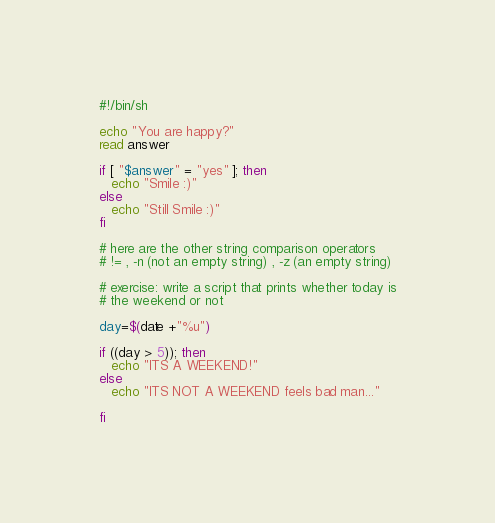<code> <loc_0><loc_0><loc_500><loc_500><_Bash_>#!/bin/sh

echo "You are happy?"
read answer

if [ "$answer" = "yes" ]; then
   echo "Smile :)"
else
   echo "Still Smile :)"
fi

# here are the other string comparison operators
# != , -n (not an empty string) , -z (an empty string)

# exercise: write a script that prints whether today is
# the weekend or not

day=$(date +"%u")

if ((day > 5)); then
   echo "ITS A WEEKEND!"        
else
   echo "ITS NOT A WEEKEND feels bad man..."

fi</code> 